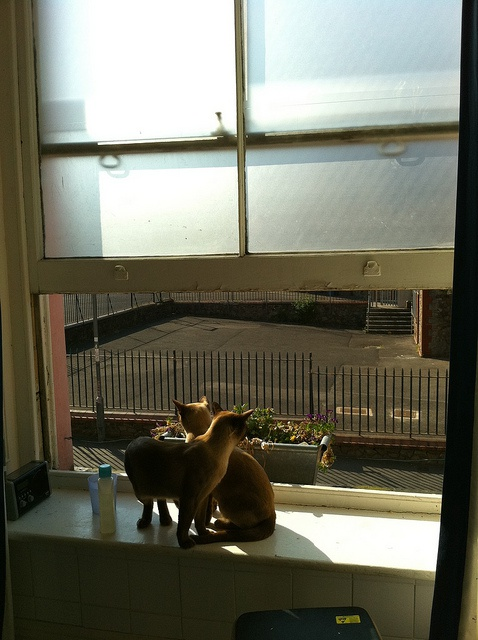Describe the objects in this image and their specific colors. I can see cat in black, maroon, and olive tones, cat in black, maroon, olive, and tan tones, and cup in black, blue, and darkblue tones in this image. 